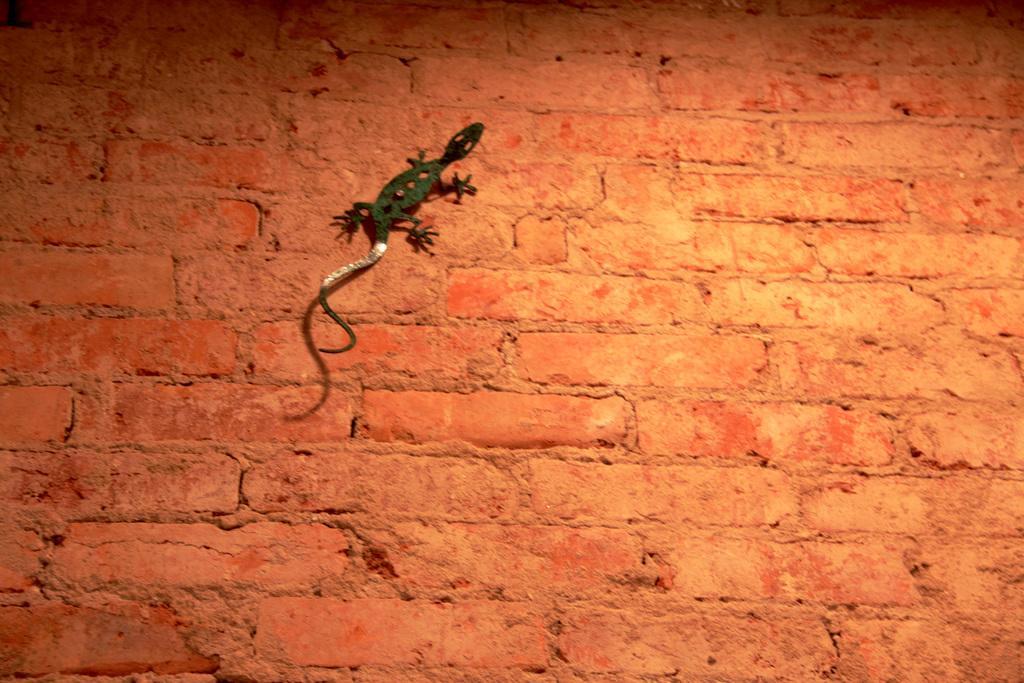Please provide a concise description of this image. In this image in the center there is one lizard on the wall. 